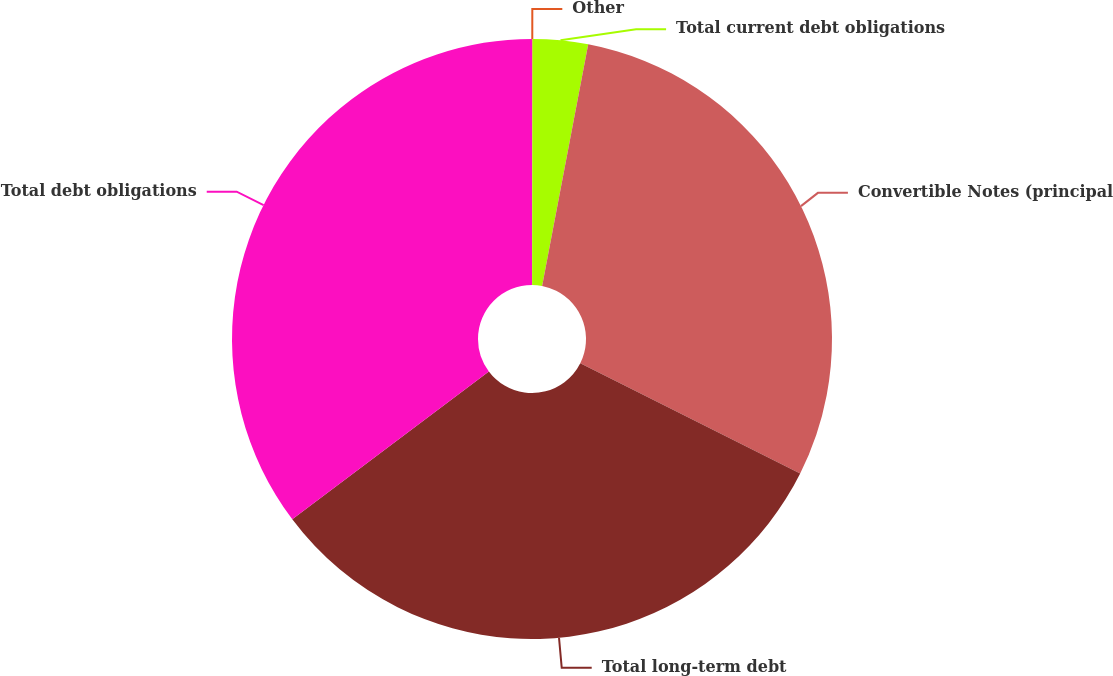<chart> <loc_0><loc_0><loc_500><loc_500><pie_chart><fcel>Other<fcel>Total current debt obligations<fcel>Convertible Notes (principal<fcel>Total long-term debt<fcel>Total debt obligations<nl><fcel>0.03%<fcel>2.97%<fcel>29.4%<fcel>32.34%<fcel>35.27%<nl></chart> 